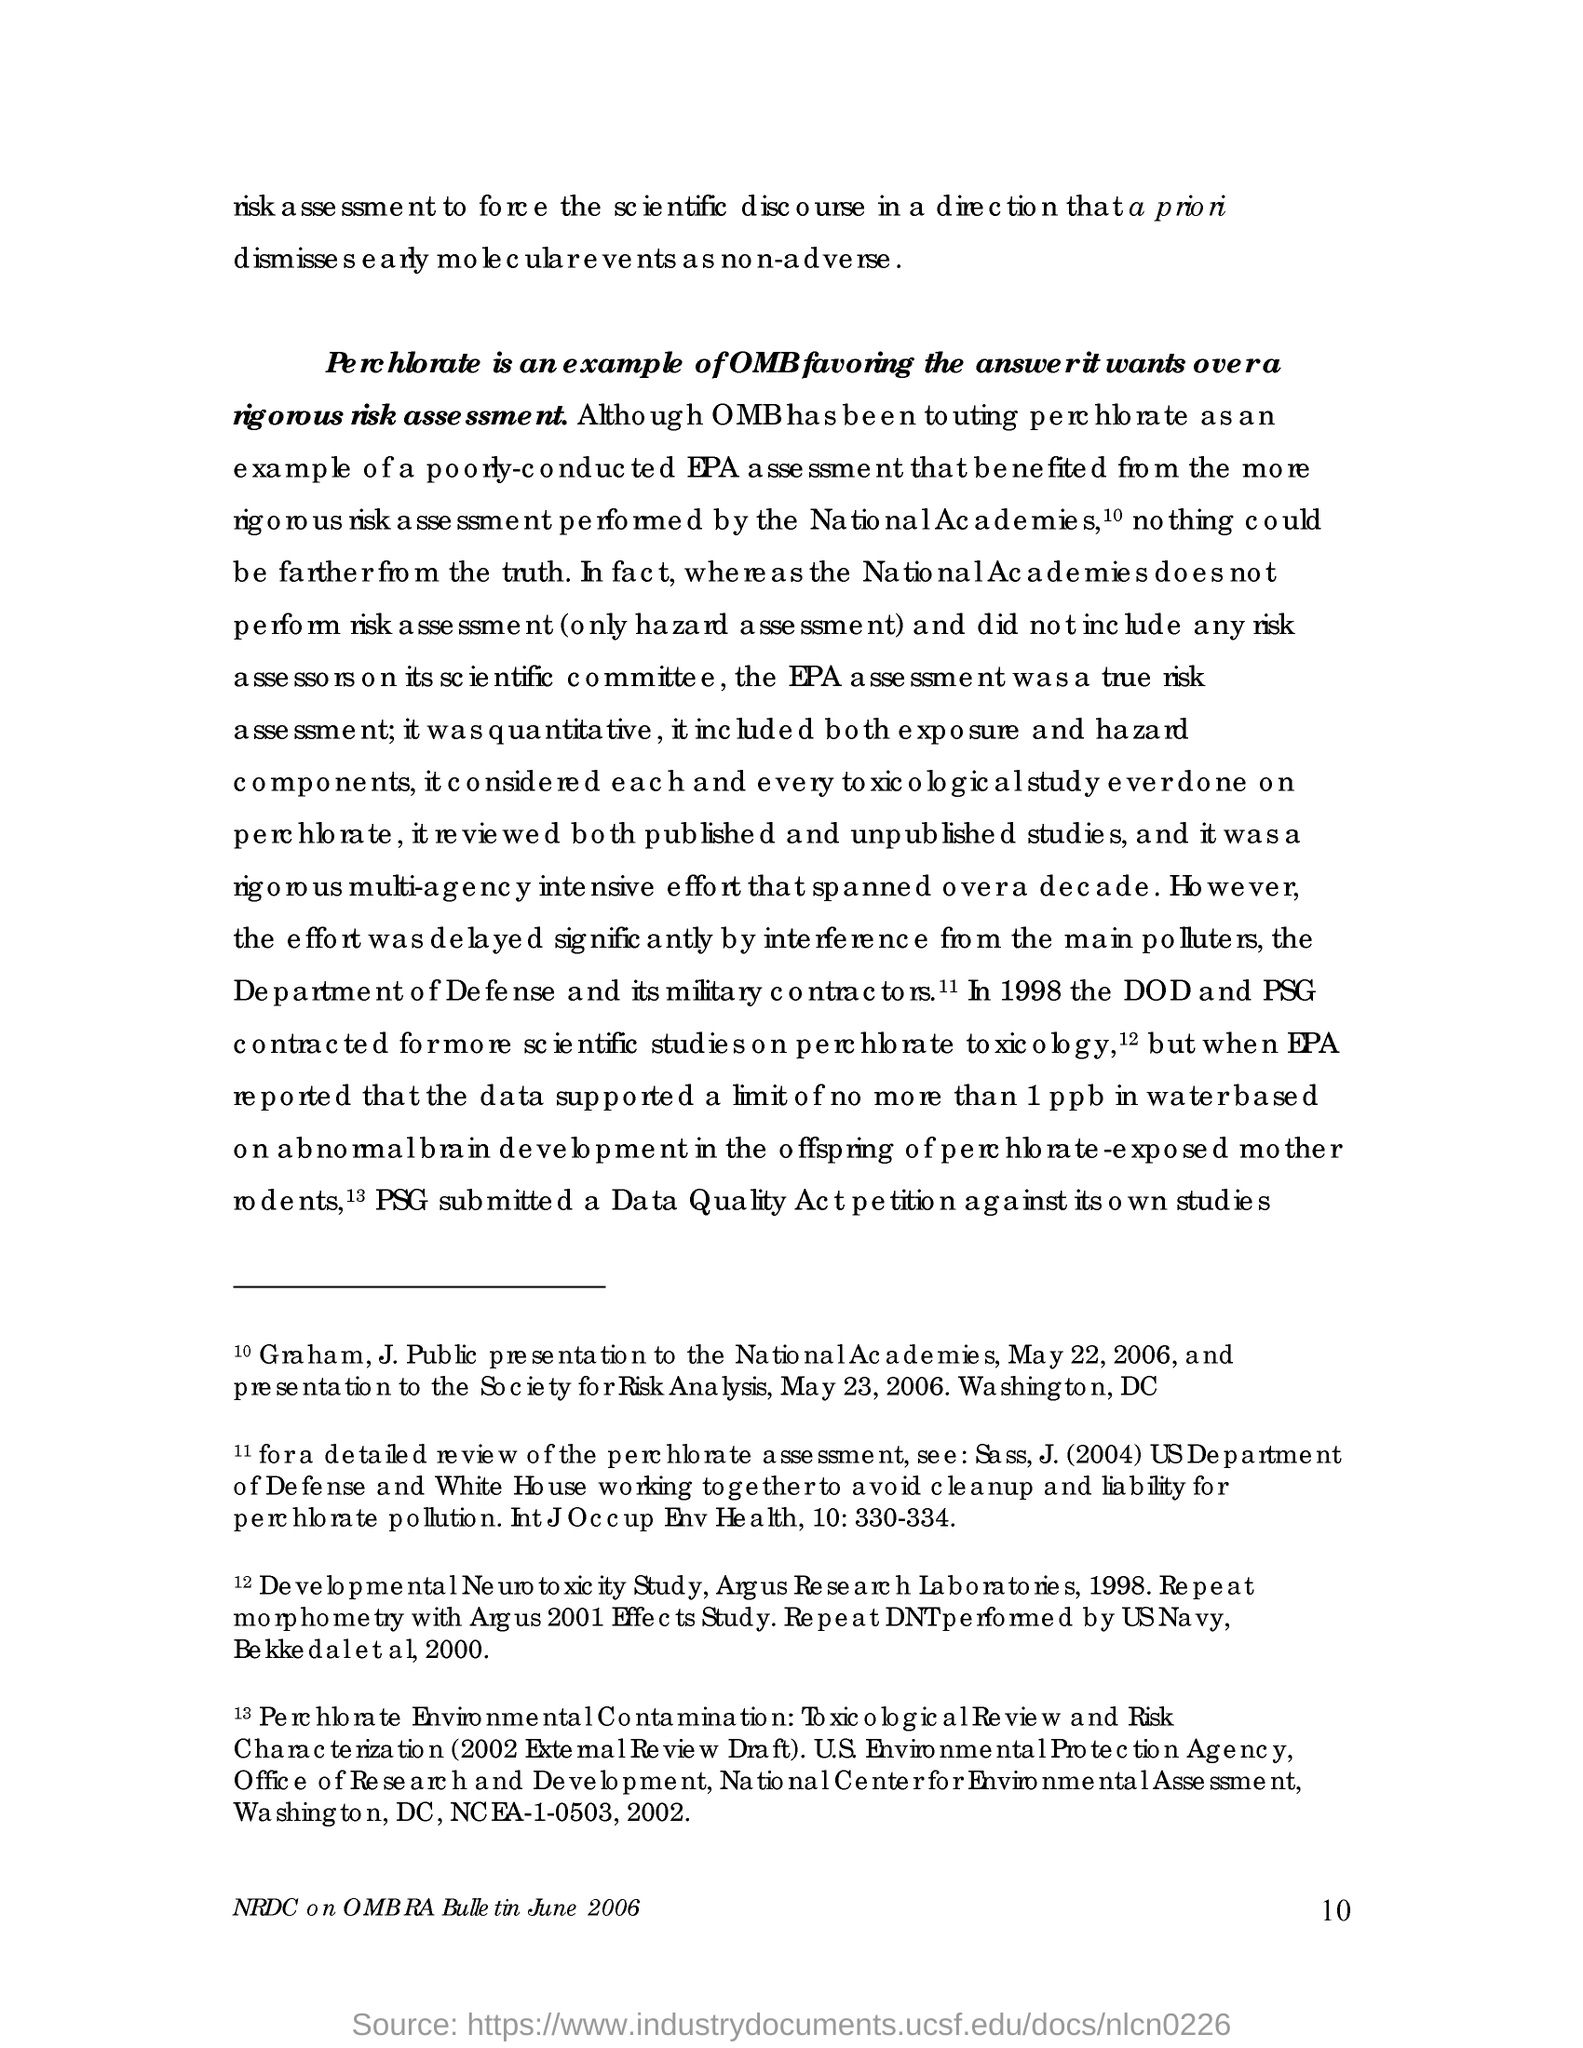Mention a couple of crucial points in this snapshot. The Department of Defense and its military contractors are considered to be the main polluters. OMB has consistently prioritized its preferred answer over rigorous risk assessments, as demonstrated by its handling of perchlorate. The risk assessment is performed by the National Academies. In 1998, the Department of Defense (DOD) and the Pacific Southwest Region of the Environmental Protection Agency (PSG) contracted for scientific studies on the toxicology of perchlorate. On May 22, 2006, Dr. Graham J. Public presented to the National Academies. 